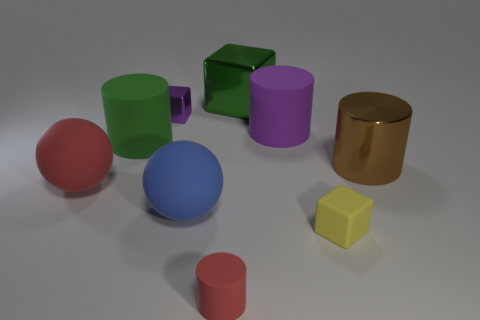Are there any green objects that have the same size as the green shiny cube?
Provide a short and direct response. Yes. How many things are either matte cylinders on the left side of the tiny red rubber thing or small blocks that are in front of the red matte sphere?
Provide a succinct answer. 2. The blue thing that is the same size as the green block is what shape?
Give a very brief answer. Sphere. Are there any yellow things of the same shape as the green metallic object?
Make the answer very short. Yes. Is the number of green rubber objects less than the number of big metallic objects?
Give a very brief answer. Yes. Is the size of the green thing to the left of the large shiny cube the same as the red matte thing that is behind the yellow thing?
Give a very brief answer. Yes. What number of objects are big red metal objects or large green shiny blocks?
Offer a very short reply. 1. What is the size of the red rubber object that is left of the purple shiny thing?
Give a very brief answer. Large. There is a large object behind the tiny object behind the yellow cube; how many purple things are to the right of it?
Your answer should be compact. 1. Is the color of the metallic cylinder the same as the tiny metal object?
Provide a succinct answer. No. 